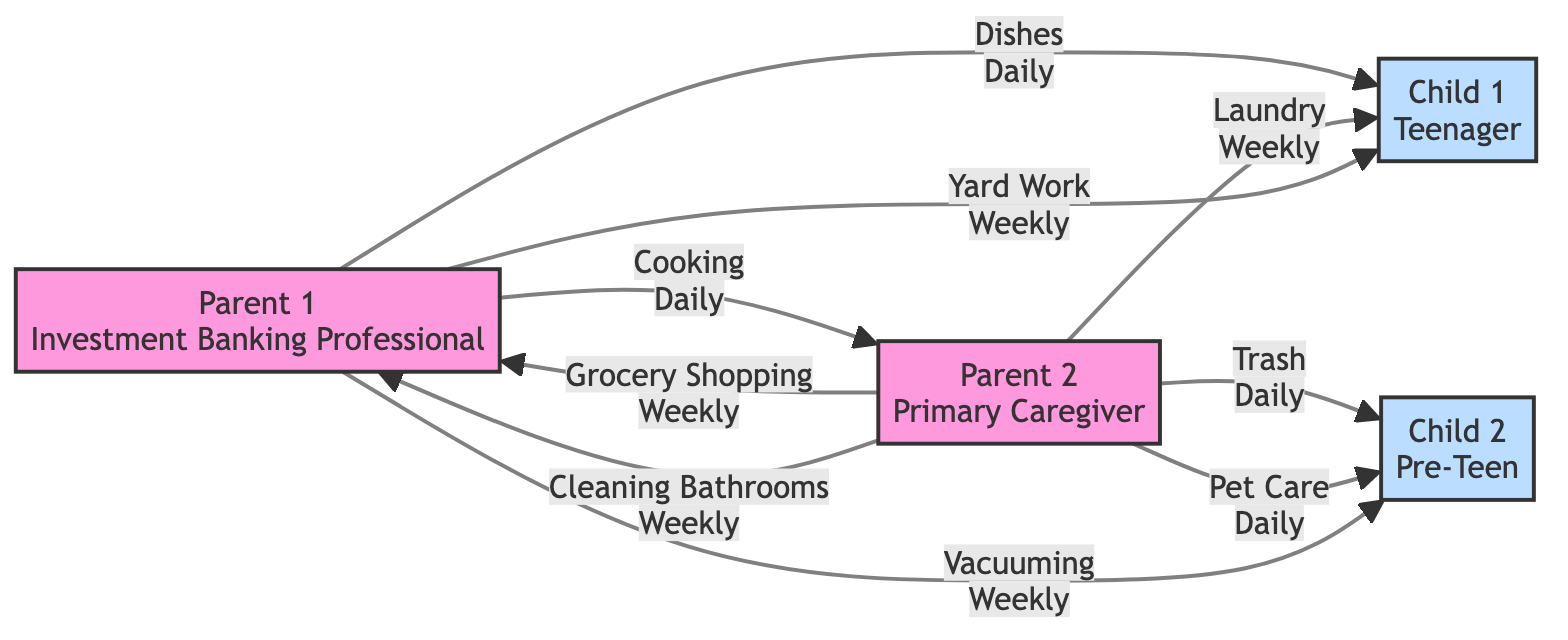What is the total number of family members in the diagram? The diagram lists four family members: Parent 1, Parent 2, Child 1, and Child 2. Counting them gives a total of four.
Answer: 4 Which family member is responsible for cooking? The diagram shows an edge directed from Parent 1 to Parent 2 labeled "Cooking". This indicates that Parent 1 is responsible for cooking for Parent 2.
Answer: Parent 1 How frequently is pet care performed? The frequency of pet care is indicated on the edge from Parent 2 to Child 2, labeled "Pet Care Daily". This means pet care is a daily task.
Answer: Daily Who is responsible for both laundry and vacuuming? Looking at the assignments, Child 1 is assigned to laundry by Parent 2 and vacuuming is assigned to Child 2 by Parent 1. So, no single individual is responsible for both.
Answer: No Which task is assigned to Child 1? The diagram indicates that Child 1 has responsibilities for "Dishes", "Laundry", and "Yard Work". Thus, there are three tasks assigned to Child 1.
Answer: Dishes, Laundry, Yard Work How many chores are performed daily? By examining the edges, we see tasks labeled "Dishes", "Trash", "Cooking", and "Pet Care". This sums up to four daily chores.
Answer: 4 Which parent has more responsibilities in the diagram? Evaluating the number of tasks assigned shows Parent 2 has the most assignments including cooking, grocery shopping, laundry, trash, pet care, and cleaning bathrooms, which is six tasks overall, compared to Parent 1’s three tasks.
Answer: Parent 2 What is the frequency of lawn care? The edge from Parent 1 to Child 1 labeled "Yard Work" indicates that lawn care, referred to as yard work, is a weekly task, as shown in the assignment.
Answer: Weekly How many weekly chores are assigned to Parent 2? The diagram indicates that Parent 2 is assigned "Grocery Shopping", "Laundry", and "Cleaning Bathrooms", summing up to three weekly chores.
Answer: 3 